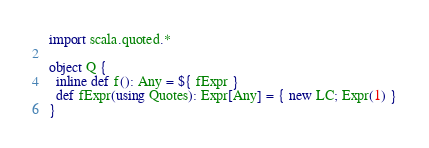<code> <loc_0><loc_0><loc_500><loc_500><_Scala_>import scala.quoted.*

object Q {
  inline def f(): Any = ${ fExpr }
  def fExpr(using Quotes): Expr[Any] = { new LC; Expr(1) }
}</code> 